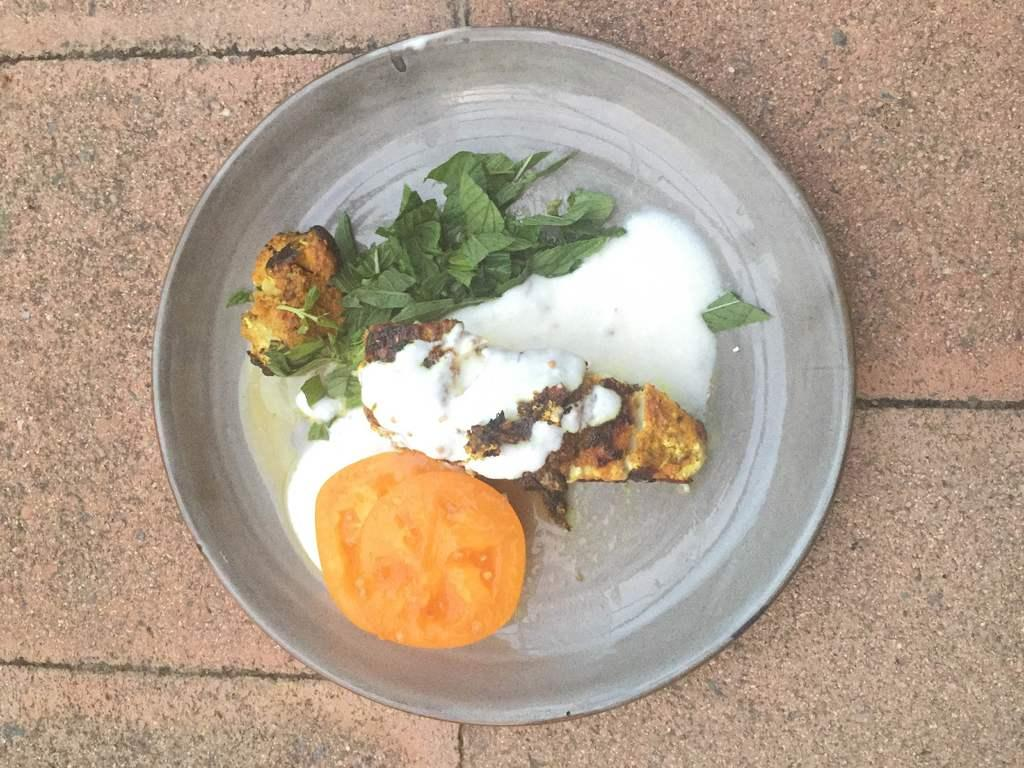What type of food is visible in the image? The food in the image includes coriander leaves and tomato slices. How is the food arranged or presented? The food is placed on a silver plate. What is the color of the ground beneath the plate? The ground beneath the plate is brown in color. How many cherries are present on the silver plate in the image? There are no cherries visible in the image; the food includes coriander leaves and tomato slices. 